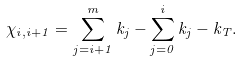<formula> <loc_0><loc_0><loc_500><loc_500>\chi _ { i , i + 1 } = \sum _ { j = i + 1 } ^ { m } k _ { j } - \sum _ { j = 0 } ^ { i } k _ { j } - k _ { T } . \,</formula> 